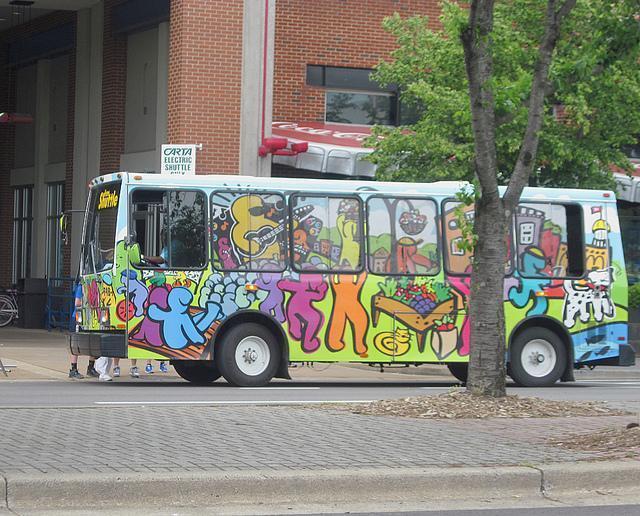How many people are there?
Give a very brief answer. 1. How many chairs do you see?
Give a very brief answer. 0. 